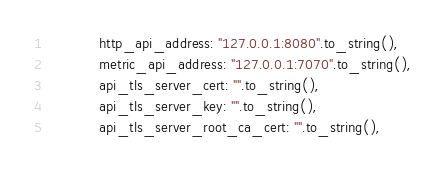<code> <loc_0><loc_0><loc_500><loc_500><_Rust_>            http_api_address: "127.0.0.1:8080".to_string(),
            metric_api_address: "127.0.0.1:7070".to_string(),
            api_tls_server_cert: "".to_string(),
            api_tls_server_key: "".to_string(),
            api_tls_server_root_ca_cert: "".to_string(),</code> 